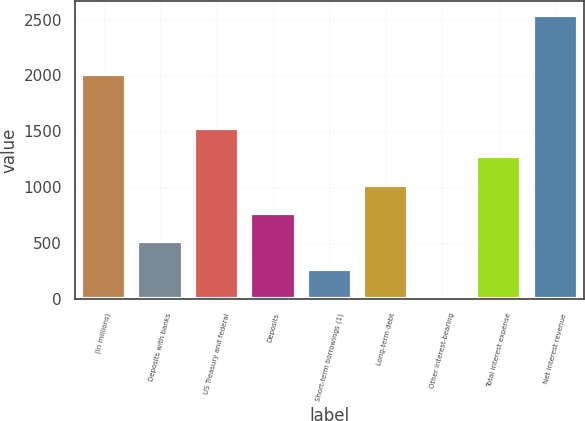<chart> <loc_0><loc_0><loc_500><loc_500><bar_chart><fcel>(In millions)<fcel>Deposits with banks<fcel>US Treasury and federal<fcel>Deposits<fcel>Short-term borrowings (1)<fcel>Long-term debt<fcel>Other interest-bearing<fcel>Total interest expense<fcel>Net interest revenue<nl><fcel>2012<fcel>519.6<fcel>1528.8<fcel>771.9<fcel>267.3<fcel>1024.2<fcel>15<fcel>1276.5<fcel>2538<nl></chart> 